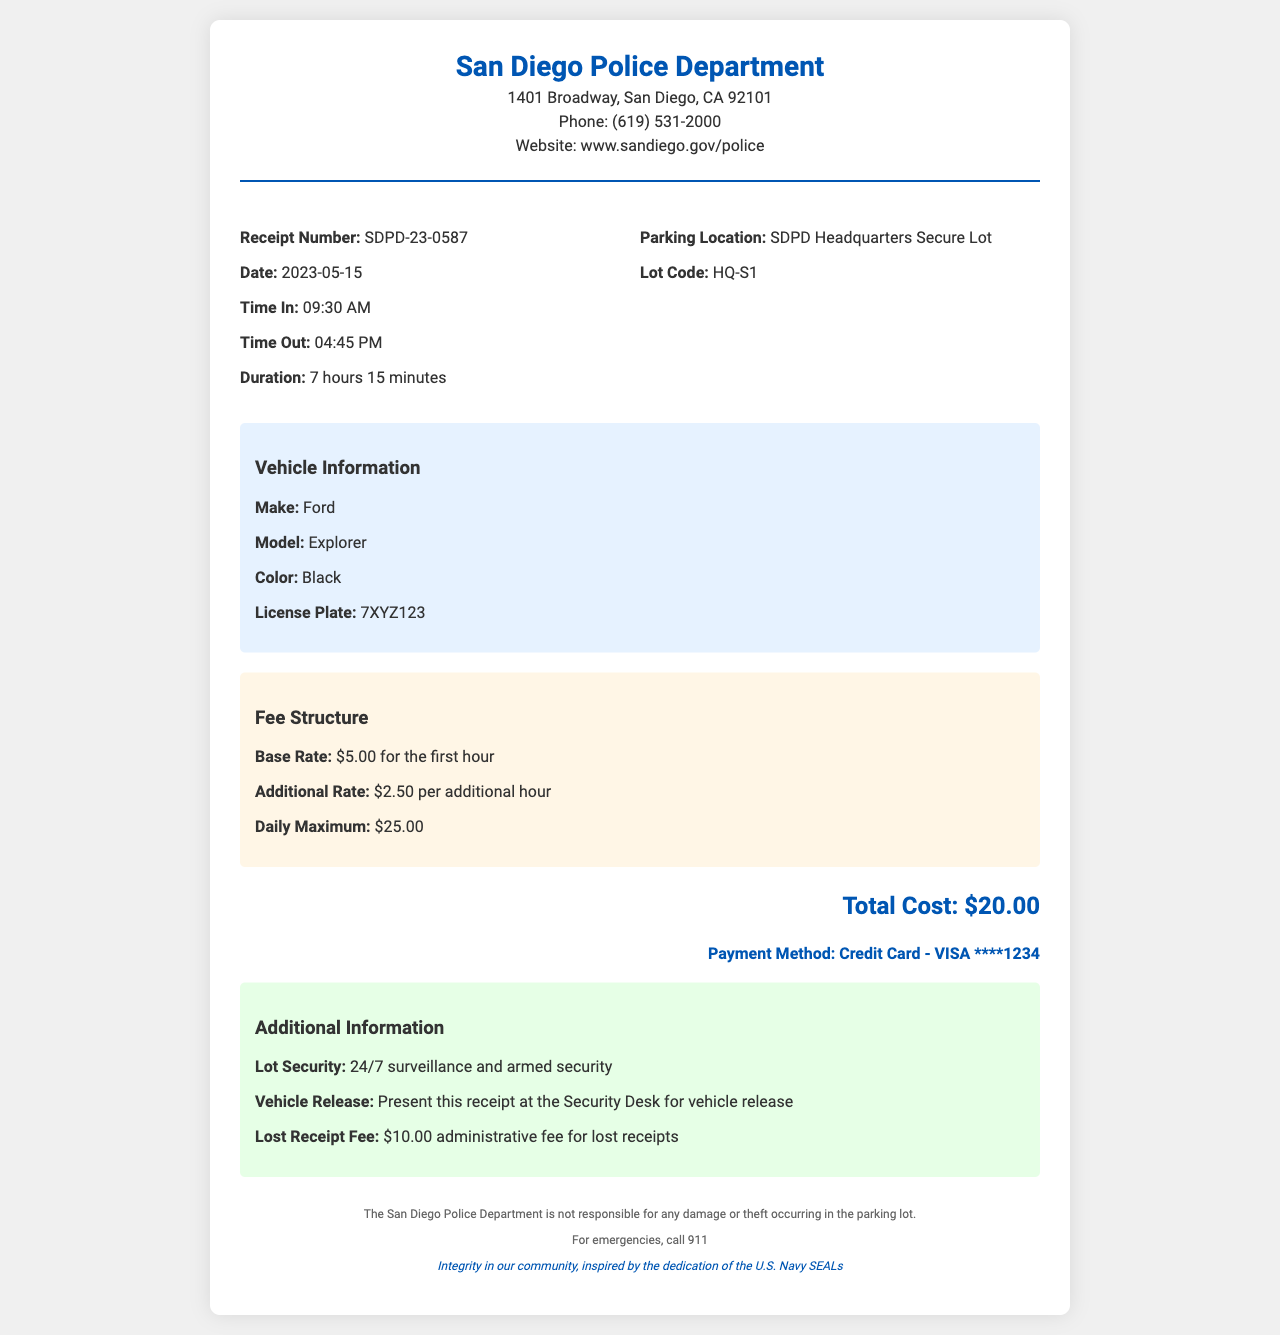what is the total cost? The total cost is stated in the document as $20.00.
Answer: $20.00 what is the duration of parking? The duration of parking is provided as 7 hours 15 minutes.
Answer: 7 hours 15 minutes what is the vehicle's license plate? The vehicle's license plate is listed in the vehicle information section.
Answer: 7XYZ123 what is the date of the receipt? The date of the receipt is provided in the receipt details section.
Answer: 2023-05-15 what is the maximum daily parking fee? The maximum daily parking fee is found in the fee structure section.
Answer: $25.00 which lot is the parking located? The name of the parking lot is specified in the parking location section.
Answer: SDPD Headquarters Secure Lot how much is the lost receipt fee? The fee for a lost receipt is mentioned in the additional information section.
Answer: $10.00 administrative fee what is the payment method used? The payment method is noted in the total cost section of the receipt.
Answer: Credit Card - VISA ****1234 who does the receipt belong to? The receipt is issued by the San Diego Police Department, noted at the top of the document.
Answer: San Diego Police Department 